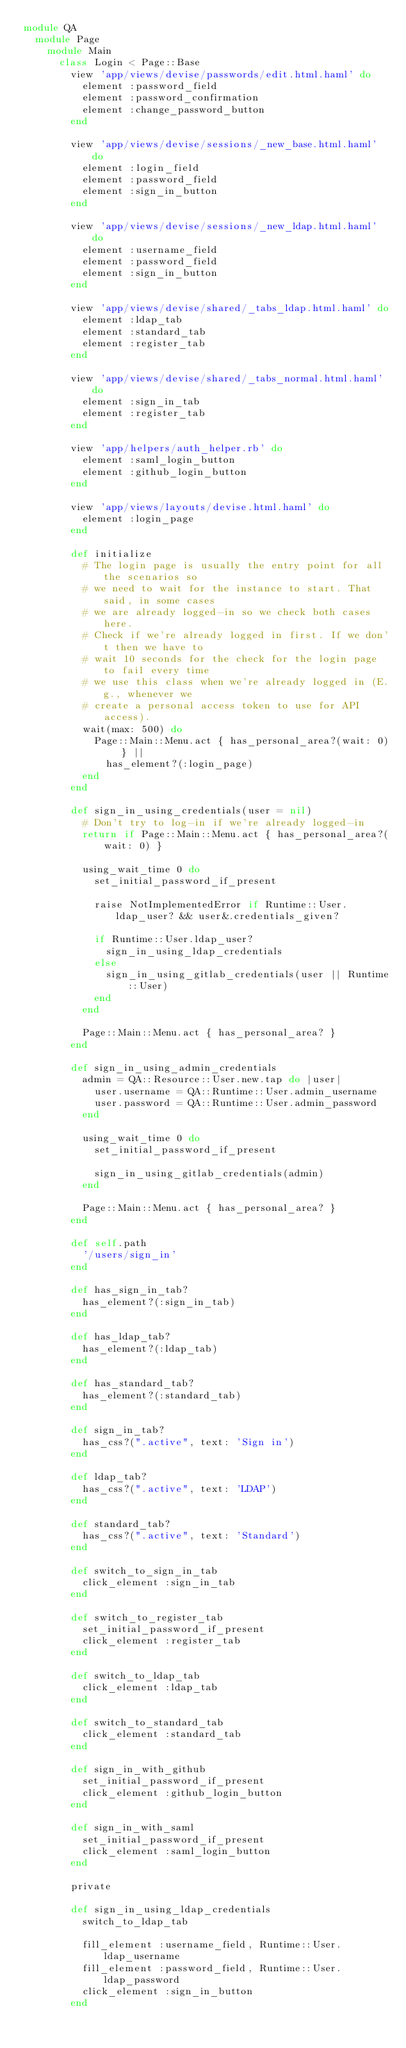Convert code to text. <code><loc_0><loc_0><loc_500><loc_500><_Ruby_>module QA
  module Page
    module Main
      class Login < Page::Base
        view 'app/views/devise/passwords/edit.html.haml' do
          element :password_field
          element :password_confirmation
          element :change_password_button
        end

        view 'app/views/devise/sessions/_new_base.html.haml' do
          element :login_field
          element :password_field
          element :sign_in_button
        end

        view 'app/views/devise/sessions/_new_ldap.html.haml' do
          element :username_field
          element :password_field
          element :sign_in_button
        end

        view 'app/views/devise/shared/_tabs_ldap.html.haml' do
          element :ldap_tab
          element :standard_tab
          element :register_tab
        end

        view 'app/views/devise/shared/_tabs_normal.html.haml' do
          element :sign_in_tab
          element :register_tab
        end

        view 'app/helpers/auth_helper.rb' do
          element :saml_login_button
          element :github_login_button
        end

        view 'app/views/layouts/devise.html.haml' do
          element :login_page
        end

        def initialize
          # The login page is usually the entry point for all the scenarios so
          # we need to wait for the instance to start. That said, in some cases
          # we are already logged-in so we check both cases here.
          # Check if we're already logged in first. If we don't then we have to
          # wait 10 seconds for the check for the login page to fail every time
          # we use this class when we're already logged in (E.g., whenever we
          # create a personal access token to use for API access).
          wait(max: 500) do
            Page::Main::Menu.act { has_personal_area?(wait: 0) } ||
              has_element?(:login_page)
          end
        end

        def sign_in_using_credentials(user = nil)
          # Don't try to log-in if we're already logged-in
          return if Page::Main::Menu.act { has_personal_area?(wait: 0) }

          using_wait_time 0 do
            set_initial_password_if_present

            raise NotImplementedError if Runtime::User.ldap_user? && user&.credentials_given?

            if Runtime::User.ldap_user?
              sign_in_using_ldap_credentials
            else
              sign_in_using_gitlab_credentials(user || Runtime::User)
            end
          end

          Page::Main::Menu.act { has_personal_area? }
        end

        def sign_in_using_admin_credentials
          admin = QA::Resource::User.new.tap do |user|
            user.username = QA::Runtime::User.admin_username
            user.password = QA::Runtime::User.admin_password
          end

          using_wait_time 0 do
            set_initial_password_if_present

            sign_in_using_gitlab_credentials(admin)
          end

          Page::Main::Menu.act { has_personal_area? }
        end

        def self.path
          '/users/sign_in'
        end

        def has_sign_in_tab?
          has_element?(:sign_in_tab)
        end

        def has_ldap_tab?
          has_element?(:ldap_tab)
        end

        def has_standard_tab?
          has_element?(:standard_tab)
        end

        def sign_in_tab?
          has_css?(".active", text: 'Sign in')
        end

        def ldap_tab?
          has_css?(".active", text: 'LDAP')
        end

        def standard_tab?
          has_css?(".active", text: 'Standard')
        end

        def switch_to_sign_in_tab
          click_element :sign_in_tab
        end

        def switch_to_register_tab
          set_initial_password_if_present
          click_element :register_tab
        end

        def switch_to_ldap_tab
          click_element :ldap_tab
        end

        def switch_to_standard_tab
          click_element :standard_tab
        end

        def sign_in_with_github
          set_initial_password_if_present
          click_element :github_login_button
        end

        def sign_in_with_saml
          set_initial_password_if_present
          click_element :saml_login_button
        end

        private

        def sign_in_using_ldap_credentials
          switch_to_ldap_tab

          fill_element :username_field, Runtime::User.ldap_username
          fill_element :password_field, Runtime::User.ldap_password
          click_element :sign_in_button
        end
</code> 